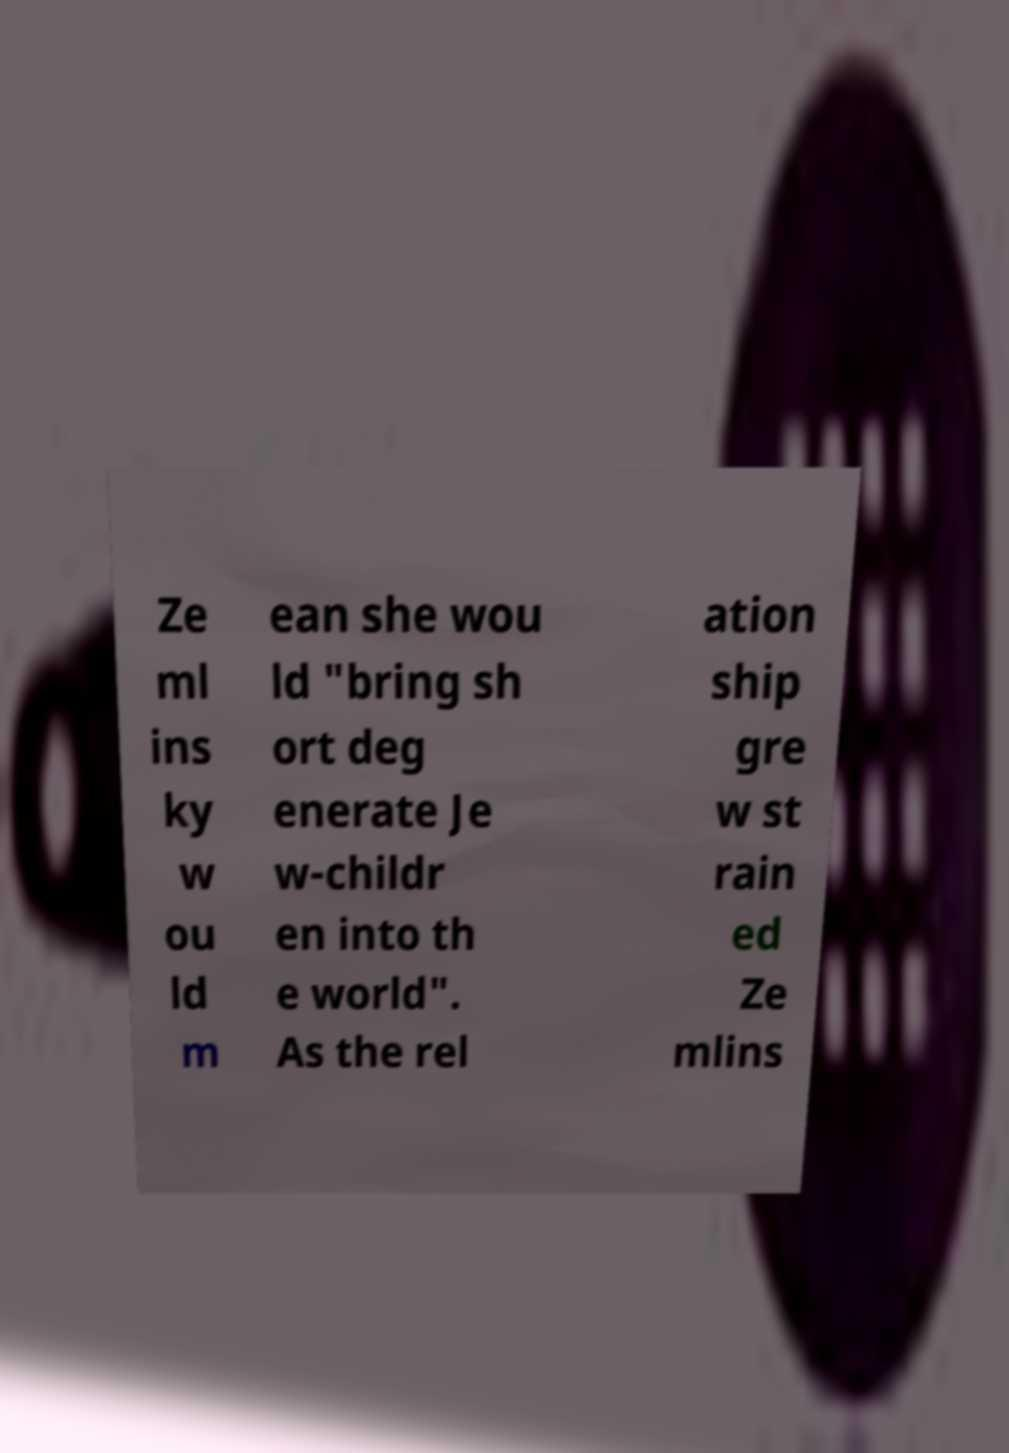I need the written content from this picture converted into text. Can you do that? Ze ml ins ky w ou ld m ean she wou ld "bring sh ort deg enerate Je w-childr en into th e world". As the rel ation ship gre w st rain ed Ze mlins 